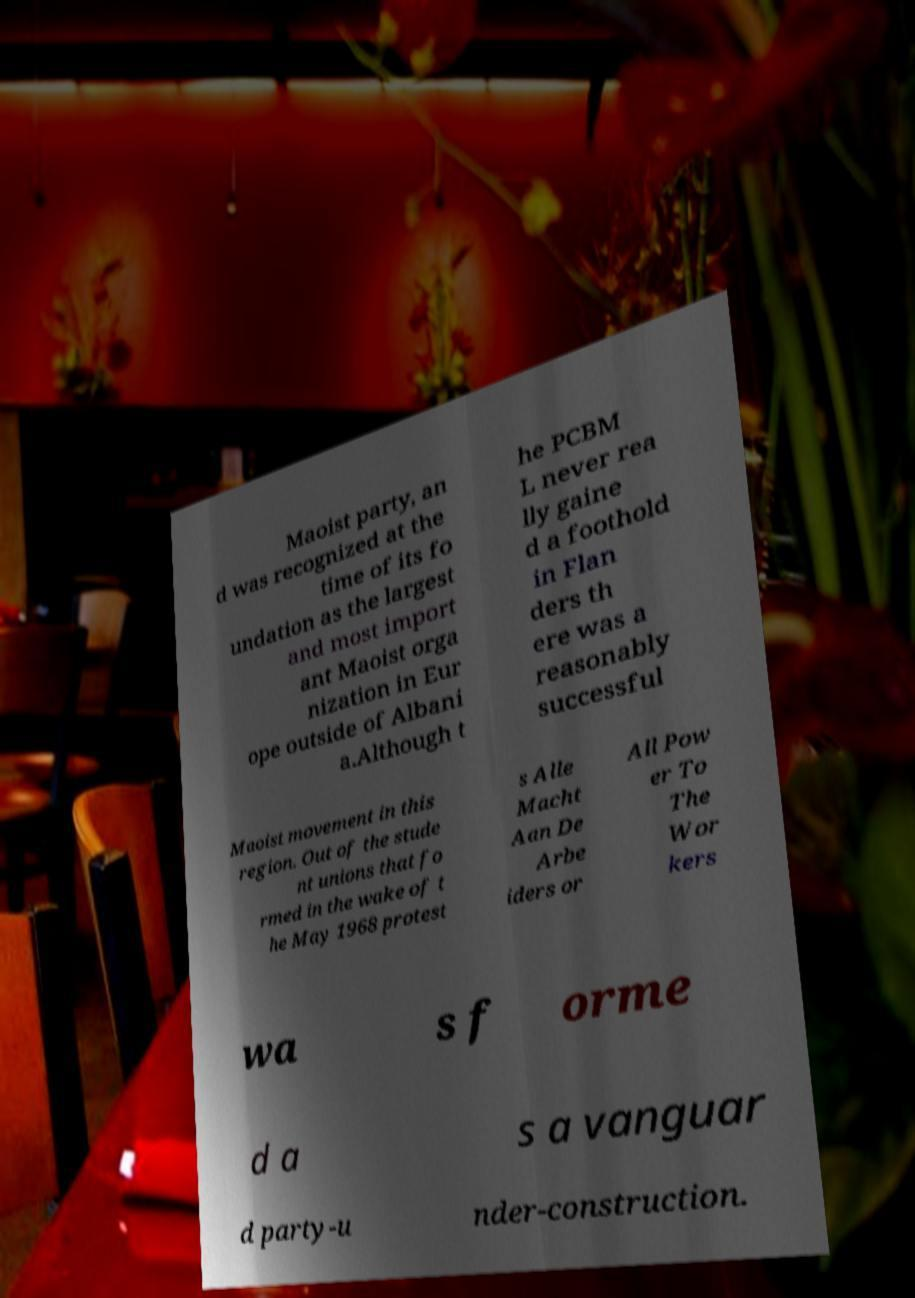There's text embedded in this image that I need extracted. Can you transcribe it verbatim? Maoist party, an d was recognized at the time of its fo undation as the largest and most import ant Maoist orga nization in Eur ope outside of Albani a.Although t he PCBM L never rea lly gaine d a foothold in Flan ders th ere was a reasonably successful Maoist movement in this region. Out of the stude nt unions that fo rmed in the wake of t he May 1968 protest s Alle Macht Aan De Arbe iders or All Pow er To The Wor kers wa s f orme d a s a vanguar d party-u nder-construction. 